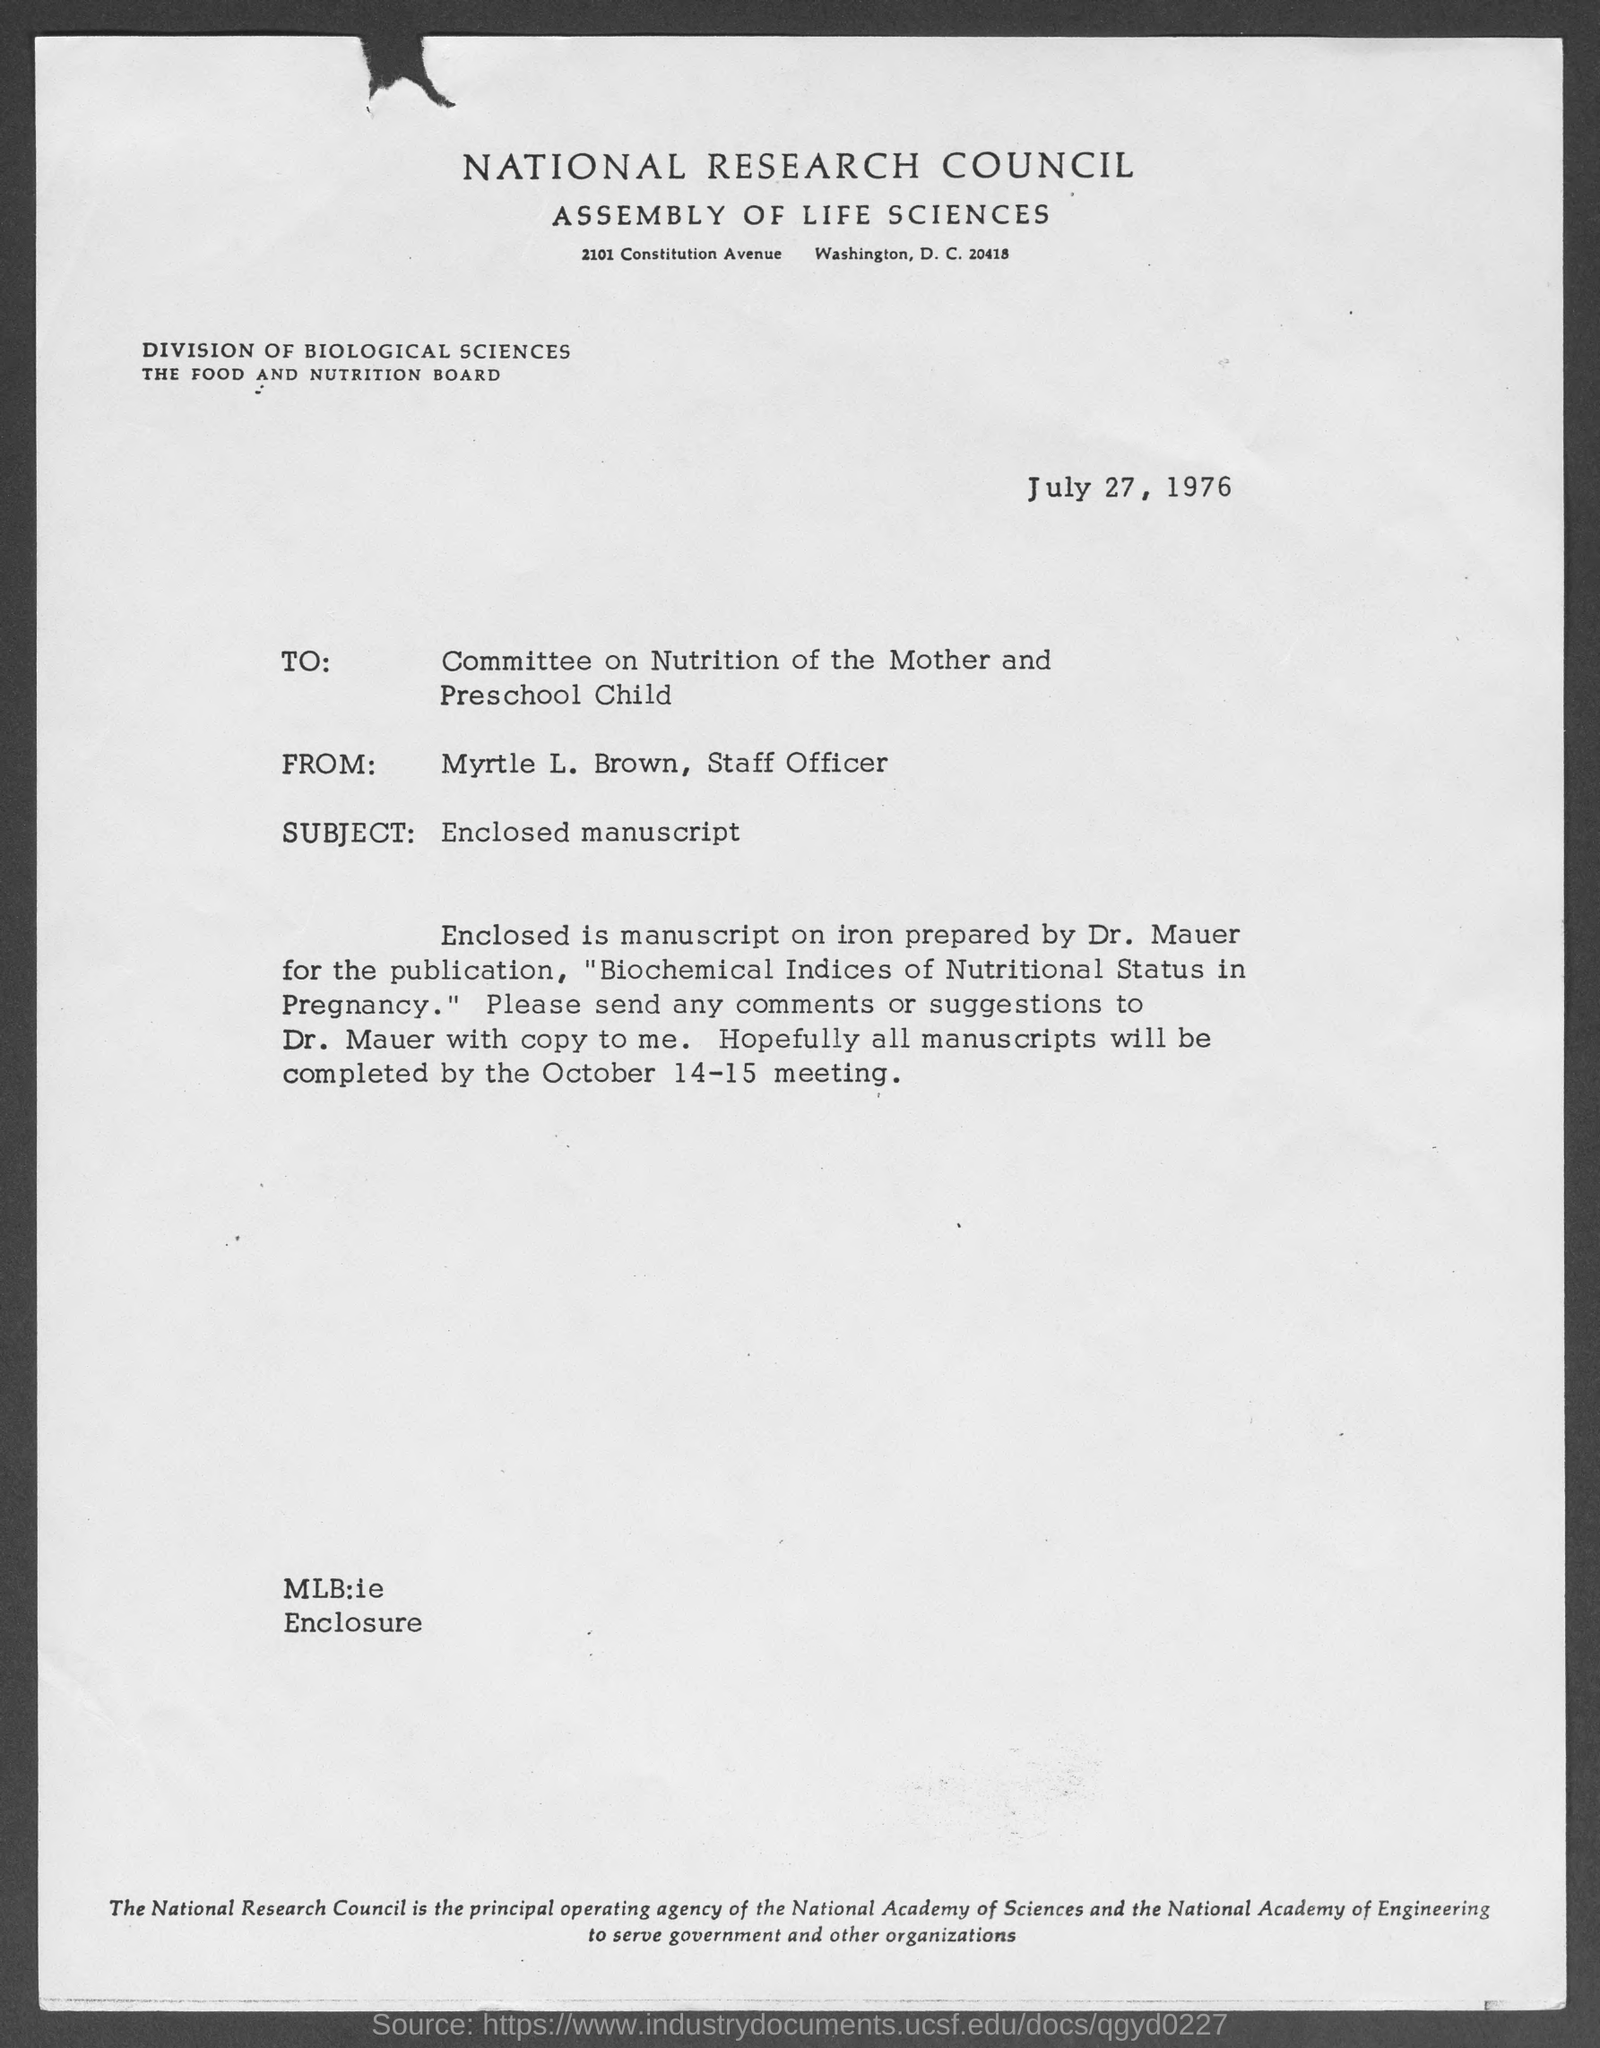Could you describe the role of Myrtle L. Brown mentioned in the document? Myrtle L. Brown is described as a Staff Officer in the document. Her role likely involved overseeing and coordinating the research and publication processes within the National Research Council, particularly pertaining to projects like the one discussed in the document.  What is the significance of the Committee on Nutrition of the Mother and Preschool Child? The Committee on Nutrition of the Mother and Preschool Child focuses on nutritional issues and guidelines specific to pregnant women and young children. Its work is crucial for developing recommendations that safeguard and enhance the health and developmental outcomes for these sensitive groups. 